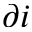<formula> <loc_0><loc_0><loc_500><loc_500>\partial i</formula> 